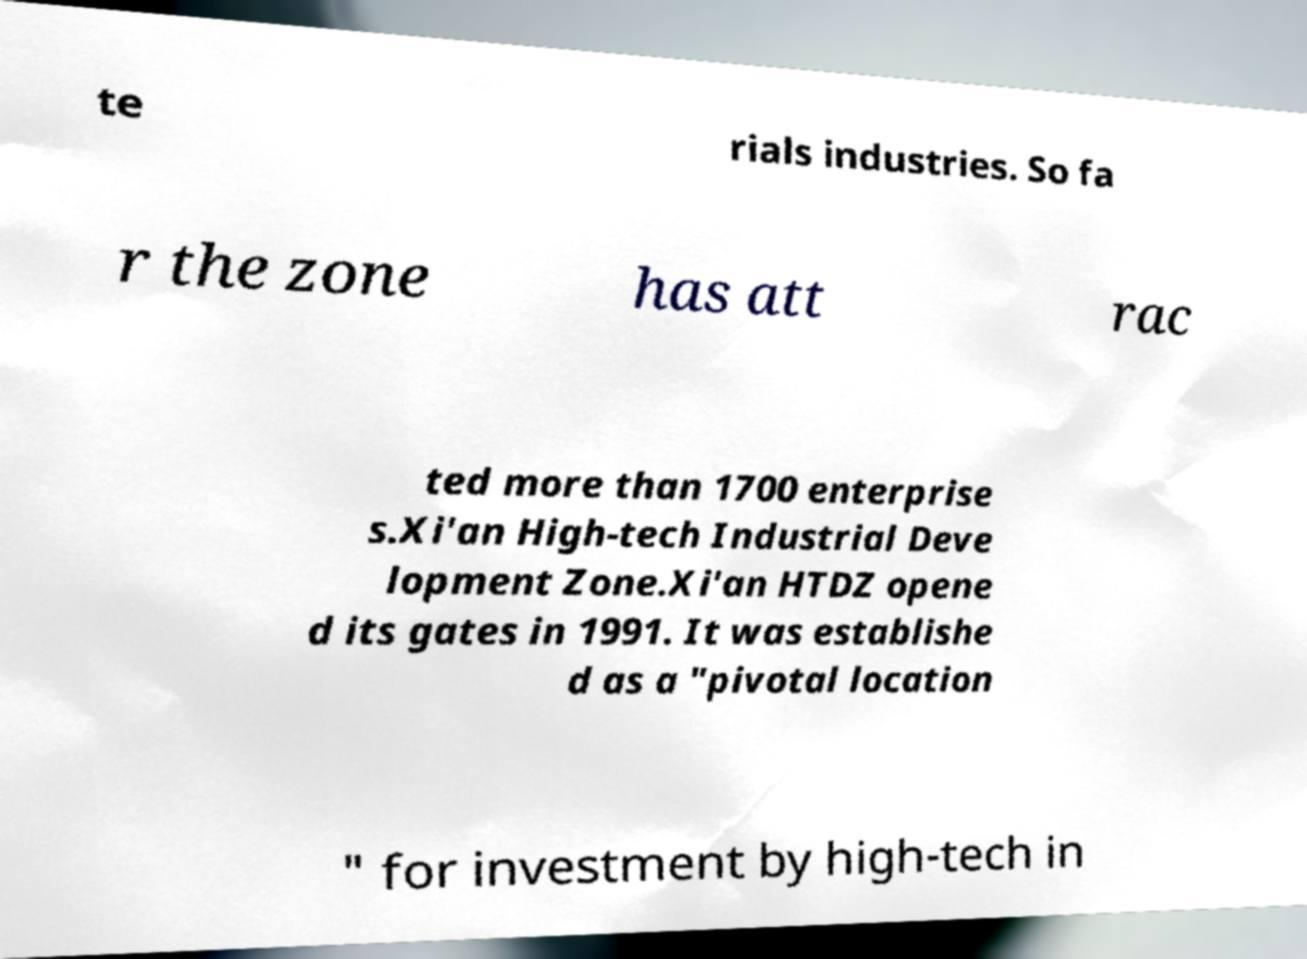Could you assist in decoding the text presented in this image and type it out clearly? te rials industries. So fa r the zone has att rac ted more than 1700 enterprise s.Xi'an High-tech Industrial Deve lopment Zone.Xi'an HTDZ opene d its gates in 1991. It was establishe d as a "pivotal location " for investment by high-tech in 